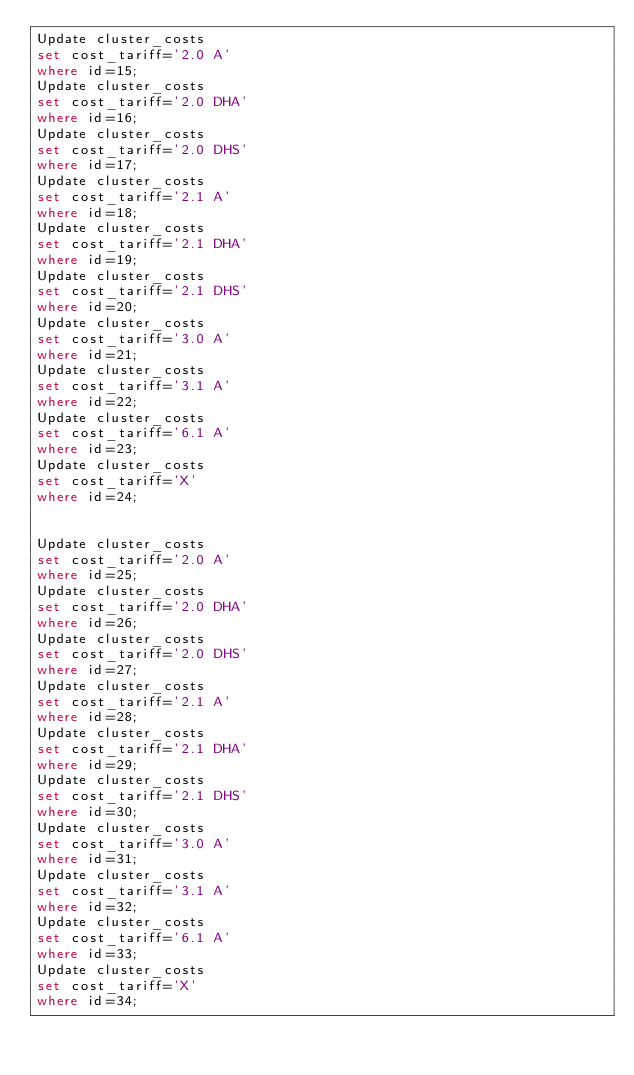Convert code to text. <code><loc_0><loc_0><loc_500><loc_500><_SQL_>Update cluster_costs
set cost_tariff='2.0 A'
where id=15;
Update cluster_costs
set cost_tariff='2.0 DHA'
where id=16;
Update cluster_costs
set cost_tariff='2.0 DHS'
where id=17;
Update cluster_costs
set cost_tariff='2.1 A'
where id=18;
Update cluster_costs
set cost_tariff='2.1 DHA'
where id=19;
Update cluster_costs
set cost_tariff='2.1 DHS'
where id=20;
Update cluster_costs
set cost_tariff='3.0 A'
where id=21;
Update cluster_costs
set cost_tariff='3.1 A'
where id=22;
Update cluster_costs
set cost_tariff='6.1 A'
where id=23;
Update cluster_costs
set cost_tariff='X'
where id=24;


Update cluster_costs
set cost_tariff='2.0 A'
where id=25;
Update cluster_costs
set cost_tariff='2.0 DHA'
where id=26;
Update cluster_costs
set cost_tariff='2.0 DHS'
where id=27;
Update cluster_costs
set cost_tariff='2.1 A'
where id=28;
Update cluster_costs
set cost_tariff='2.1 DHA'
where id=29;
Update cluster_costs
set cost_tariff='2.1 DHS'
where id=30;
Update cluster_costs
set cost_tariff='3.0 A'
where id=31;
Update cluster_costs
set cost_tariff='3.1 A'
where id=32;
Update cluster_costs
set cost_tariff='6.1 A'
where id=33;
Update cluster_costs
set cost_tariff='X'
where id=34;</code> 